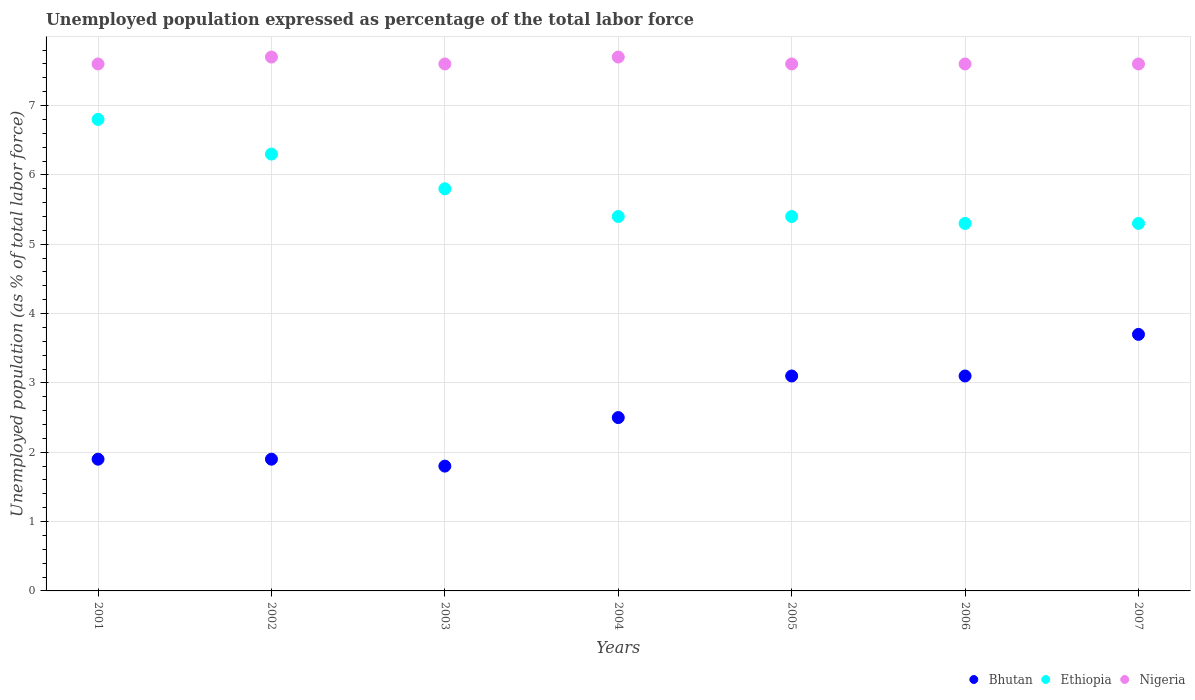Is the number of dotlines equal to the number of legend labels?
Keep it short and to the point. Yes. What is the unemployment in in Bhutan in 2007?
Provide a succinct answer. 3.7. Across all years, what is the maximum unemployment in in Nigeria?
Provide a short and direct response. 7.7. Across all years, what is the minimum unemployment in in Ethiopia?
Offer a terse response. 5.3. In which year was the unemployment in in Bhutan minimum?
Ensure brevity in your answer.  2003. What is the total unemployment in in Ethiopia in the graph?
Your answer should be very brief. 40.3. What is the difference between the unemployment in in Nigeria in 2002 and that in 2006?
Keep it short and to the point. 0.1. What is the difference between the unemployment in in Nigeria in 2005 and the unemployment in in Bhutan in 2007?
Your response must be concise. 3.9. What is the average unemployment in in Ethiopia per year?
Offer a very short reply. 5.76. In the year 2006, what is the difference between the unemployment in in Ethiopia and unemployment in in Nigeria?
Provide a succinct answer. -2.3. In how many years, is the unemployment in in Bhutan greater than 7.4 %?
Provide a succinct answer. 0. What is the ratio of the unemployment in in Ethiopia in 2001 to that in 2007?
Provide a succinct answer. 1.28. Is the difference between the unemployment in in Ethiopia in 2002 and 2005 greater than the difference between the unemployment in in Nigeria in 2002 and 2005?
Give a very brief answer. Yes. What is the difference between the highest and the second highest unemployment in in Ethiopia?
Keep it short and to the point. 0.5. What is the difference between the highest and the lowest unemployment in in Nigeria?
Offer a terse response. 0.1. Does the unemployment in in Ethiopia monotonically increase over the years?
Offer a very short reply. No. Is the unemployment in in Ethiopia strictly greater than the unemployment in in Nigeria over the years?
Provide a short and direct response. No. How many dotlines are there?
Provide a succinct answer. 3. Are the values on the major ticks of Y-axis written in scientific E-notation?
Your answer should be very brief. No. Does the graph contain any zero values?
Offer a terse response. No. Does the graph contain grids?
Make the answer very short. Yes. How are the legend labels stacked?
Give a very brief answer. Horizontal. What is the title of the graph?
Your response must be concise. Unemployed population expressed as percentage of the total labor force. Does "Congo (Democratic)" appear as one of the legend labels in the graph?
Ensure brevity in your answer.  No. What is the label or title of the Y-axis?
Give a very brief answer. Unemployed population (as % of total labor force). What is the Unemployed population (as % of total labor force) in Bhutan in 2001?
Provide a short and direct response. 1.9. What is the Unemployed population (as % of total labor force) in Ethiopia in 2001?
Offer a terse response. 6.8. What is the Unemployed population (as % of total labor force) of Nigeria in 2001?
Offer a terse response. 7.6. What is the Unemployed population (as % of total labor force) in Bhutan in 2002?
Provide a short and direct response. 1.9. What is the Unemployed population (as % of total labor force) in Ethiopia in 2002?
Your answer should be compact. 6.3. What is the Unemployed population (as % of total labor force) of Nigeria in 2002?
Your response must be concise. 7.7. What is the Unemployed population (as % of total labor force) in Bhutan in 2003?
Your answer should be very brief. 1.8. What is the Unemployed population (as % of total labor force) of Ethiopia in 2003?
Provide a short and direct response. 5.8. What is the Unemployed population (as % of total labor force) of Nigeria in 2003?
Make the answer very short. 7.6. What is the Unemployed population (as % of total labor force) in Bhutan in 2004?
Ensure brevity in your answer.  2.5. What is the Unemployed population (as % of total labor force) of Ethiopia in 2004?
Your answer should be very brief. 5.4. What is the Unemployed population (as % of total labor force) in Nigeria in 2004?
Your answer should be very brief. 7.7. What is the Unemployed population (as % of total labor force) in Bhutan in 2005?
Provide a succinct answer. 3.1. What is the Unemployed population (as % of total labor force) in Ethiopia in 2005?
Keep it short and to the point. 5.4. What is the Unemployed population (as % of total labor force) in Nigeria in 2005?
Offer a very short reply. 7.6. What is the Unemployed population (as % of total labor force) in Bhutan in 2006?
Offer a very short reply. 3.1. What is the Unemployed population (as % of total labor force) of Ethiopia in 2006?
Give a very brief answer. 5.3. What is the Unemployed population (as % of total labor force) in Nigeria in 2006?
Your answer should be compact. 7.6. What is the Unemployed population (as % of total labor force) of Bhutan in 2007?
Offer a terse response. 3.7. What is the Unemployed population (as % of total labor force) in Ethiopia in 2007?
Keep it short and to the point. 5.3. What is the Unemployed population (as % of total labor force) of Nigeria in 2007?
Your answer should be very brief. 7.6. Across all years, what is the maximum Unemployed population (as % of total labor force) of Bhutan?
Give a very brief answer. 3.7. Across all years, what is the maximum Unemployed population (as % of total labor force) in Ethiopia?
Make the answer very short. 6.8. Across all years, what is the maximum Unemployed population (as % of total labor force) in Nigeria?
Your response must be concise. 7.7. Across all years, what is the minimum Unemployed population (as % of total labor force) of Bhutan?
Provide a succinct answer. 1.8. Across all years, what is the minimum Unemployed population (as % of total labor force) in Ethiopia?
Provide a short and direct response. 5.3. Across all years, what is the minimum Unemployed population (as % of total labor force) in Nigeria?
Give a very brief answer. 7.6. What is the total Unemployed population (as % of total labor force) in Bhutan in the graph?
Give a very brief answer. 18. What is the total Unemployed population (as % of total labor force) of Ethiopia in the graph?
Offer a terse response. 40.3. What is the total Unemployed population (as % of total labor force) of Nigeria in the graph?
Offer a very short reply. 53.4. What is the difference between the Unemployed population (as % of total labor force) of Ethiopia in 2001 and that in 2002?
Offer a terse response. 0.5. What is the difference between the Unemployed population (as % of total labor force) of Nigeria in 2001 and that in 2003?
Offer a very short reply. 0. What is the difference between the Unemployed population (as % of total labor force) in Bhutan in 2001 and that in 2004?
Keep it short and to the point. -0.6. What is the difference between the Unemployed population (as % of total labor force) of Nigeria in 2001 and that in 2004?
Offer a terse response. -0.1. What is the difference between the Unemployed population (as % of total labor force) of Bhutan in 2001 and that in 2005?
Keep it short and to the point. -1.2. What is the difference between the Unemployed population (as % of total labor force) in Bhutan in 2001 and that in 2006?
Your answer should be very brief. -1.2. What is the difference between the Unemployed population (as % of total labor force) of Ethiopia in 2001 and that in 2006?
Make the answer very short. 1.5. What is the difference between the Unemployed population (as % of total labor force) of Nigeria in 2001 and that in 2006?
Your answer should be compact. 0. What is the difference between the Unemployed population (as % of total labor force) in Bhutan in 2001 and that in 2007?
Offer a terse response. -1.8. What is the difference between the Unemployed population (as % of total labor force) of Nigeria in 2001 and that in 2007?
Keep it short and to the point. 0. What is the difference between the Unemployed population (as % of total labor force) in Bhutan in 2002 and that in 2003?
Offer a terse response. 0.1. What is the difference between the Unemployed population (as % of total labor force) in Ethiopia in 2002 and that in 2003?
Provide a succinct answer. 0.5. What is the difference between the Unemployed population (as % of total labor force) in Nigeria in 2002 and that in 2003?
Offer a terse response. 0.1. What is the difference between the Unemployed population (as % of total labor force) of Ethiopia in 2002 and that in 2004?
Your answer should be compact. 0.9. What is the difference between the Unemployed population (as % of total labor force) in Bhutan in 2002 and that in 2005?
Keep it short and to the point. -1.2. What is the difference between the Unemployed population (as % of total labor force) of Nigeria in 2002 and that in 2005?
Offer a terse response. 0.1. What is the difference between the Unemployed population (as % of total labor force) in Ethiopia in 2002 and that in 2007?
Your answer should be very brief. 1. What is the difference between the Unemployed population (as % of total labor force) of Ethiopia in 2003 and that in 2005?
Offer a very short reply. 0.4. What is the difference between the Unemployed population (as % of total labor force) in Nigeria in 2003 and that in 2005?
Your answer should be very brief. 0. What is the difference between the Unemployed population (as % of total labor force) of Bhutan in 2003 and that in 2006?
Ensure brevity in your answer.  -1.3. What is the difference between the Unemployed population (as % of total labor force) in Ethiopia in 2003 and that in 2006?
Your answer should be very brief. 0.5. What is the difference between the Unemployed population (as % of total labor force) in Nigeria in 2003 and that in 2006?
Provide a succinct answer. 0. What is the difference between the Unemployed population (as % of total labor force) in Bhutan in 2003 and that in 2007?
Give a very brief answer. -1.9. What is the difference between the Unemployed population (as % of total labor force) in Ethiopia in 2003 and that in 2007?
Your response must be concise. 0.5. What is the difference between the Unemployed population (as % of total labor force) in Nigeria in 2003 and that in 2007?
Keep it short and to the point. 0. What is the difference between the Unemployed population (as % of total labor force) of Bhutan in 2004 and that in 2005?
Your answer should be compact. -0.6. What is the difference between the Unemployed population (as % of total labor force) of Ethiopia in 2004 and that in 2005?
Your response must be concise. 0. What is the difference between the Unemployed population (as % of total labor force) in Bhutan in 2004 and that in 2006?
Make the answer very short. -0.6. What is the difference between the Unemployed population (as % of total labor force) of Bhutan in 2004 and that in 2007?
Your answer should be very brief. -1.2. What is the difference between the Unemployed population (as % of total labor force) of Ethiopia in 2004 and that in 2007?
Give a very brief answer. 0.1. What is the difference between the Unemployed population (as % of total labor force) in Nigeria in 2004 and that in 2007?
Provide a succinct answer. 0.1. What is the difference between the Unemployed population (as % of total labor force) in Bhutan in 2005 and that in 2006?
Your answer should be very brief. 0. What is the difference between the Unemployed population (as % of total labor force) in Ethiopia in 2005 and that in 2006?
Make the answer very short. 0.1. What is the difference between the Unemployed population (as % of total labor force) of Bhutan in 2006 and that in 2007?
Offer a terse response. -0.6. What is the difference between the Unemployed population (as % of total labor force) of Ethiopia in 2001 and the Unemployed population (as % of total labor force) of Nigeria in 2002?
Provide a succinct answer. -0.9. What is the difference between the Unemployed population (as % of total labor force) of Bhutan in 2001 and the Unemployed population (as % of total labor force) of Nigeria in 2003?
Offer a terse response. -5.7. What is the difference between the Unemployed population (as % of total labor force) of Bhutan in 2001 and the Unemployed population (as % of total labor force) of Nigeria in 2004?
Your answer should be very brief. -5.8. What is the difference between the Unemployed population (as % of total labor force) of Bhutan in 2001 and the Unemployed population (as % of total labor force) of Ethiopia in 2006?
Provide a short and direct response. -3.4. What is the difference between the Unemployed population (as % of total labor force) of Bhutan in 2001 and the Unemployed population (as % of total labor force) of Nigeria in 2006?
Keep it short and to the point. -5.7. What is the difference between the Unemployed population (as % of total labor force) in Ethiopia in 2001 and the Unemployed population (as % of total labor force) in Nigeria in 2006?
Provide a succinct answer. -0.8. What is the difference between the Unemployed population (as % of total labor force) of Ethiopia in 2001 and the Unemployed population (as % of total labor force) of Nigeria in 2007?
Offer a very short reply. -0.8. What is the difference between the Unemployed population (as % of total labor force) in Ethiopia in 2002 and the Unemployed population (as % of total labor force) in Nigeria in 2004?
Ensure brevity in your answer.  -1.4. What is the difference between the Unemployed population (as % of total labor force) of Bhutan in 2002 and the Unemployed population (as % of total labor force) of Ethiopia in 2005?
Provide a succinct answer. -3.5. What is the difference between the Unemployed population (as % of total labor force) of Ethiopia in 2002 and the Unemployed population (as % of total labor force) of Nigeria in 2005?
Make the answer very short. -1.3. What is the difference between the Unemployed population (as % of total labor force) in Ethiopia in 2002 and the Unemployed population (as % of total labor force) in Nigeria in 2006?
Your answer should be compact. -1.3. What is the difference between the Unemployed population (as % of total labor force) in Bhutan in 2002 and the Unemployed population (as % of total labor force) in Nigeria in 2007?
Your response must be concise. -5.7. What is the difference between the Unemployed population (as % of total labor force) of Bhutan in 2003 and the Unemployed population (as % of total labor force) of Ethiopia in 2004?
Keep it short and to the point. -3.6. What is the difference between the Unemployed population (as % of total labor force) in Ethiopia in 2003 and the Unemployed population (as % of total labor force) in Nigeria in 2004?
Provide a succinct answer. -1.9. What is the difference between the Unemployed population (as % of total labor force) in Bhutan in 2003 and the Unemployed population (as % of total labor force) in Ethiopia in 2005?
Your response must be concise. -3.6. What is the difference between the Unemployed population (as % of total labor force) of Bhutan in 2003 and the Unemployed population (as % of total labor force) of Nigeria in 2005?
Make the answer very short. -5.8. What is the difference between the Unemployed population (as % of total labor force) of Bhutan in 2003 and the Unemployed population (as % of total labor force) of Ethiopia in 2006?
Your answer should be compact. -3.5. What is the difference between the Unemployed population (as % of total labor force) of Bhutan in 2003 and the Unemployed population (as % of total labor force) of Nigeria in 2006?
Offer a very short reply. -5.8. What is the difference between the Unemployed population (as % of total labor force) of Ethiopia in 2003 and the Unemployed population (as % of total labor force) of Nigeria in 2007?
Offer a terse response. -1.8. What is the difference between the Unemployed population (as % of total labor force) of Bhutan in 2004 and the Unemployed population (as % of total labor force) of Nigeria in 2005?
Offer a very short reply. -5.1. What is the difference between the Unemployed population (as % of total labor force) in Ethiopia in 2004 and the Unemployed population (as % of total labor force) in Nigeria in 2005?
Your answer should be very brief. -2.2. What is the difference between the Unemployed population (as % of total labor force) of Bhutan in 2004 and the Unemployed population (as % of total labor force) of Nigeria in 2006?
Your answer should be compact. -5.1. What is the difference between the Unemployed population (as % of total labor force) in Ethiopia in 2004 and the Unemployed population (as % of total labor force) in Nigeria in 2006?
Give a very brief answer. -2.2. What is the difference between the Unemployed population (as % of total labor force) of Bhutan in 2004 and the Unemployed population (as % of total labor force) of Nigeria in 2007?
Offer a very short reply. -5.1. What is the difference between the Unemployed population (as % of total labor force) of Ethiopia in 2004 and the Unemployed population (as % of total labor force) of Nigeria in 2007?
Offer a terse response. -2.2. What is the difference between the Unemployed population (as % of total labor force) of Bhutan in 2005 and the Unemployed population (as % of total labor force) of Ethiopia in 2006?
Offer a terse response. -2.2. What is the difference between the Unemployed population (as % of total labor force) in Ethiopia in 2005 and the Unemployed population (as % of total labor force) in Nigeria in 2006?
Give a very brief answer. -2.2. What is the difference between the Unemployed population (as % of total labor force) of Bhutan in 2005 and the Unemployed population (as % of total labor force) of Ethiopia in 2007?
Offer a terse response. -2.2. What is the difference between the Unemployed population (as % of total labor force) in Bhutan in 2005 and the Unemployed population (as % of total labor force) in Nigeria in 2007?
Keep it short and to the point. -4.5. What is the difference between the Unemployed population (as % of total labor force) of Ethiopia in 2006 and the Unemployed population (as % of total labor force) of Nigeria in 2007?
Your response must be concise. -2.3. What is the average Unemployed population (as % of total labor force) in Bhutan per year?
Keep it short and to the point. 2.57. What is the average Unemployed population (as % of total labor force) in Ethiopia per year?
Your answer should be very brief. 5.76. What is the average Unemployed population (as % of total labor force) in Nigeria per year?
Ensure brevity in your answer.  7.63. In the year 2001, what is the difference between the Unemployed population (as % of total labor force) of Bhutan and Unemployed population (as % of total labor force) of Ethiopia?
Provide a succinct answer. -4.9. In the year 2001, what is the difference between the Unemployed population (as % of total labor force) in Ethiopia and Unemployed population (as % of total labor force) in Nigeria?
Offer a very short reply. -0.8. In the year 2002, what is the difference between the Unemployed population (as % of total labor force) of Ethiopia and Unemployed population (as % of total labor force) of Nigeria?
Your response must be concise. -1.4. In the year 2003, what is the difference between the Unemployed population (as % of total labor force) in Ethiopia and Unemployed population (as % of total labor force) in Nigeria?
Offer a terse response. -1.8. In the year 2004, what is the difference between the Unemployed population (as % of total labor force) in Bhutan and Unemployed population (as % of total labor force) in Ethiopia?
Make the answer very short. -2.9. In the year 2005, what is the difference between the Unemployed population (as % of total labor force) in Bhutan and Unemployed population (as % of total labor force) in Nigeria?
Your answer should be very brief. -4.5. In the year 2007, what is the difference between the Unemployed population (as % of total labor force) in Bhutan and Unemployed population (as % of total labor force) in Ethiopia?
Your response must be concise. -1.6. What is the ratio of the Unemployed population (as % of total labor force) in Ethiopia in 2001 to that in 2002?
Give a very brief answer. 1.08. What is the ratio of the Unemployed population (as % of total labor force) of Nigeria in 2001 to that in 2002?
Make the answer very short. 0.99. What is the ratio of the Unemployed population (as % of total labor force) in Bhutan in 2001 to that in 2003?
Ensure brevity in your answer.  1.06. What is the ratio of the Unemployed population (as % of total labor force) in Ethiopia in 2001 to that in 2003?
Your answer should be very brief. 1.17. What is the ratio of the Unemployed population (as % of total labor force) of Nigeria in 2001 to that in 2003?
Give a very brief answer. 1. What is the ratio of the Unemployed population (as % of total labor force) of Bhutan in 2001 to that in 2004?
Your answer should be compact. 0.76. What is the ratio of the Unemployed population (as % of total labor force) in Ethiopia in 2001 to that in 2004?
Your answer should be very brief. 1.26. What is the ratio of the Unemployed population (as % of total labor force) in Bhutan in 2001 to that in 2005?
Provide a short and direct response. 0.61. What is the ratio of the Unemployed population (as % of total labor force) in Ethiopia in 2001 to that in 2005?
Provide a succinct answer. 1.26. What is the ratio of the Unemployed population (as % of total labor force) of Bhutan in 2001 to that in 2006?
Provide a short and direct response. 0.61. What is the ratio of the Unemployed population (as % of total labor force) in Ethiopia in 2001 to that in 2006?
Give a very brief answer. 1.28. What is the ratio of the Unemployed population (as % of total labor force) in Bhutan in 2001 to that in 2007?
Your answer should be compact. 0.51. What is the ratio of the Unemployed population (as % of total labor force) in Ethiopia in 2001 to that in 2007?
Your response must be concise. 1.28. What is the ratio of the Unemployed population (as % of total labor force) in Bhutan in 2002 to that in 2003?
Give a very brief answer. 1.06. What is the ratio of the Unemployed population (as % of total labor force) in Ethiopia in 2002 to that in 2003?
Your answer should be compact. 1.09. What is the ratio of the Unemployed population (as % of total labor force) in Nigeria in 2002 to that in 2003?
Offer a terse response. 1.01. What is the ratio of the Unemployed population (as % of total labor force) of Bhutan in 2002 to that in 2004?
Provide a short and direct response. 0.76. What is the ratio of the Unemployed population (as % of total labor force) in Ethiopia in 2002 to that in 2004?
Keep it short and to the point. 1.17. What is the ratio of the Unemployed population (as % of total labor force) of Nigeria in 2002 to that in 2004?
Give a very brief answer. 1. What is the ratio of the Unemployed population (as % of total labor force) in Bhutan in 2002 to that in 2005?
Your response must be concise. 0.61. What is the ratio of the Unemployed population (as % of total labor force) in Ethiopia in 2002 to that in 2005?
Your response must be concise. 1.17. What is the ratio of the Unemployed population (as % of total labor force) in Nigeria in 2002 to that in 2005?
Provide a succinct answer. 1.01. What is the ratio of the Unemployed population (as % of total labor force) of Bhutan in 2002 to that in 2006?
Your answer should be compact. 0.61. What is the ratio of the Unemployed population (as % of total labor force) in Ethiopia in 2002 to that in 2006?
Your answer should be compact. 1.19. What is the ratio of the Unemployed population (as % of total labor force) of Nigeria in 2002 to that in 2006?
Provide a succinct answer. 1.01. What is the ratio of the Unemployed population (as % of total labor force) in Bhutan in 2002 to that in 2007?
Offer a terse response. 0.51. What is the ratio of the Unemployed population (as % of total labor force) in Ethiopia in 2002 to that in 2007?
Ensure brevity in your answer.  1.19. What is the ratio of the Unemployed population (as % of total labor force) in Nigeria in 2002 to that in 2007?
Keep it short and to the point. 1.01. What is the ratio of the Unemployed population (as % of total labor force) of Bhutan in 2003 to that in 2004?
Keep it short and to the point. 0.72. What is the ratio of the Unemployed population (as % of total labor force) in Ethiopia in 2003 to that in 2004?
Offer a terse response. 1.07. What is the ratio of the Unemployed population (as % of total labor force) of Nigeria in 2003 to that in 2004?
Your response must be concise. 0.99. What is the ratio of the Unemployed population (as % of total labor force) in Bhutan in 2003 to that in 2005?
Provide a succinct answer. 0.58. What is the ratio of the Unemployed population (as % of total labor force) in Ethiopia in 2003 to that in 2005?
Keep it short and to the point. 1.07. What is the ratio of the Unemployed population (as % of total labor force) in Bhutan in 2003 to that in 2006?
Provide a short and direct response. 0.58. What is the ratio of the Unemployed population (as % of total labor force) of Ethiopia in 2003 to that in 2006?
Ensure brevity in your answer.  1.09. What is the ratio of the Unemployed population (as % of total labor force) in Bhutan in 2003 to that in 2007?
Your answer should be very brief. 0.49. What is the ratio of the Unemployed population (as % of total labor force) in Ethiopia in 2003 to that in 2007?
Keep it short and to the point. 1.09. What is the ratio of the Unemployed population (as % of total labor force) in Nigeria in 2003 to that in 2007?
Make the answer very short. 1. What is the ratio of the Unemployed population (as % of total labor force) of Bhutan in 2004 to that in 2005?
Ensure brevity in your answer.  0.81. What is the ratio of the Unemployed population (as % of total labor force) of Ethiopia in 2004 to that in 2005?
Your answer should be very brief. 1. What is the ratio of the Unemployed population (as % of total labor force) in Nigeria in 2004 to that in 2005?
Make the answer very short. 1.01. What is the ratio of the Unemployed population (as % of total labor force) of Bhutan in 2004 to that in 2006?
Give a very brief answer. 0.81. What is the ratio of the Unemployed population (as % of total labor force) of Ethiopia in 2004 to that in 2006?
Your response must be concise. 1.02. What is the ratio of the Unemployed population (as % of total labor force) of Nigeria in 2004 to that in 2006?
Make the answer very short. 1.01. What is the ratio of the Unemployed population (as % of total labor force) of Bhutan in 2004 to that in 2007?
Your answer should be compact. 0.68. What is the ratio of the Unemployed population (as % of total labor force) of Ethiopia in 2004 to that in 2007?
Give a very brief answer. 1.02. What is the ratio of the Unemployed population (as % of total labor force) of Nigeria in 2004 to that in 2007?
Your answer should be compact. 1.01. What is the ratio of the Unemployed population (as % of total labor force) in Bhutan in 2005 to that in 2006?
Your answer should be compact. 1. What is the ratio of the Unemployed population (as % of total labor force) in Ethiopia in 2005 to that in 2006?
Provide a short and direct response. 1.02. What is the ratio of the Unemployed population (as % of total labor force) in Bhutan in 2005 to that in 2007?
Ensure brevity in your answer.  0.84. What is the ratio of the Unemployed population (as % of total labor force) of Ethiopia in 2005 to that in 2007?
Keep it short and to the point. 1.02. What is the ratio of the Unemployed population (as % of total labor force) of Nigeria in 2005 to that in 2007?
Make the answer very short. 1. What is the ratio of the Unemployed population (as % of total labor force) in Bhutan in 2006 to that in 2007?
Your answer should be compact. 0.84. What is the ratio of the Unemployed population (as % of total labor force) of Ethiopia in 2006 to that in 2007?
Keep it short and to the point. 1. What is the difference between the highest and the second highest Unemployed population (as % of total labor force) in Bhutan?
Your answer should be compact. 0.6. 